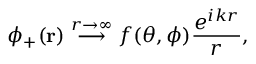<formula> <loc_0><loc_0><loc_500><loc_500>\phi _ { + } ( r ) \, { \stackrel { r \to \infty } { \longrightarrow } } \, f ( \theta , \phi ) { \frac { e ^ { i k r } } { r } } ,</formula> 